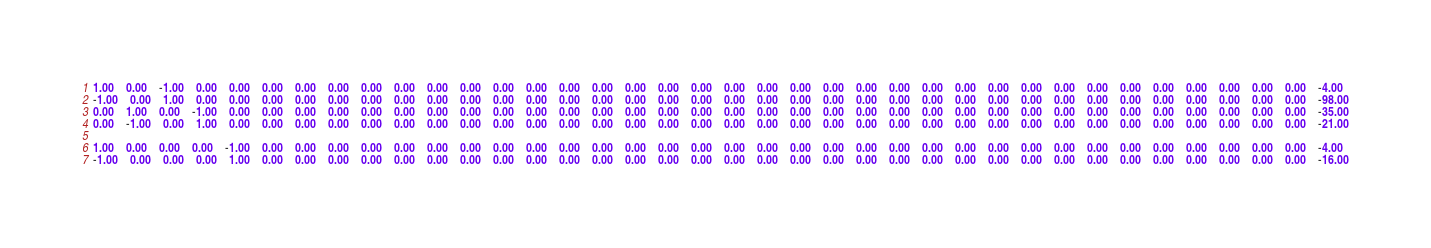<code> <loc_0><loc_0><loc_500><loc_500><_Matlab_>1.00	0.00	-1.00	0.00	0.00	0.00	0.00	0.00	0.00	0.00	0.00	0.00	0.00	0.00	0.00	0.00	0.00	0.00	0.00	0.00	0.00	0.00	0.00	0.00	0.00	0.00	0.00	0.00	0.00	0.00	0.00	0.00	0.00	0.00	0.00	0.00	0.00	-4.00
-1.00	0.00	1.00	0.00	0.00	0.00	0.00	0.00	0.00	0.00	0.00	0.00	0.00	0.00	0.00	0.00	0.00	0.00	0.00	0.00	0.00	0.00	0.00	0.00	0.00	0.00	0.00	0.00	0.00	0.00	0.00	0.00	0.00	0.00	0.00	0.00	0.00	-98.00
0.00	1.00	0.00	-1.00	0.00	0.00	0.00	0.00	0.00	0.00	0.00	0.00	0.00	0.00	0.00	0.00	0.00	0.00	0.00	0.00	0.00	0.00	0.00	0.00	0.00	0.00	0.00	0.00	0.00	0.00	0.00	0.00	0.00	0.00	0.00	0.00	0.00	-35.00
0.00	-1.00	0.00	1.00	0.00	0.00	0.00	0.00	0.00	0.00	0.00	0.00	0.00	0.00	0.00	0.00	0.00	0.00	0.00	0.00	0.00	0.00	0.00	0.00	0.00	0.00	0.00	0.00	0.00	0.00	0.00	0.00	0.00	0.00	0.00	0.00	0.00	-21.00

1.00	0.00	0.00	0.00	-1.00	0.00	0.00	0.00	0.00	0.00	0.00	0.00	0.00	0.00	0.00	0.00	0.00	0.00	0.00	0.00	0.00	0.00	0.00	0.00	0.00	0.00	0.00	0.00	0.00	0.00	0.00	0.00	0.00	0.00	0.00	0.00	0.00	-4.00
-1.00	0.00	0.00	0.00	1.00	0.00	0.00	0.00	0.00	0.00	0.00	0.00	0.00	0.00	0.00	0.00	0.00	0.00	0.00	0.00	0.00	0.00	0.00	0.00	0.00	0.00	0.00	0.00	0.00	0.00	0.00	0.00	0.00	0.00	0.00	0.00	0.00	-16.00</code> 